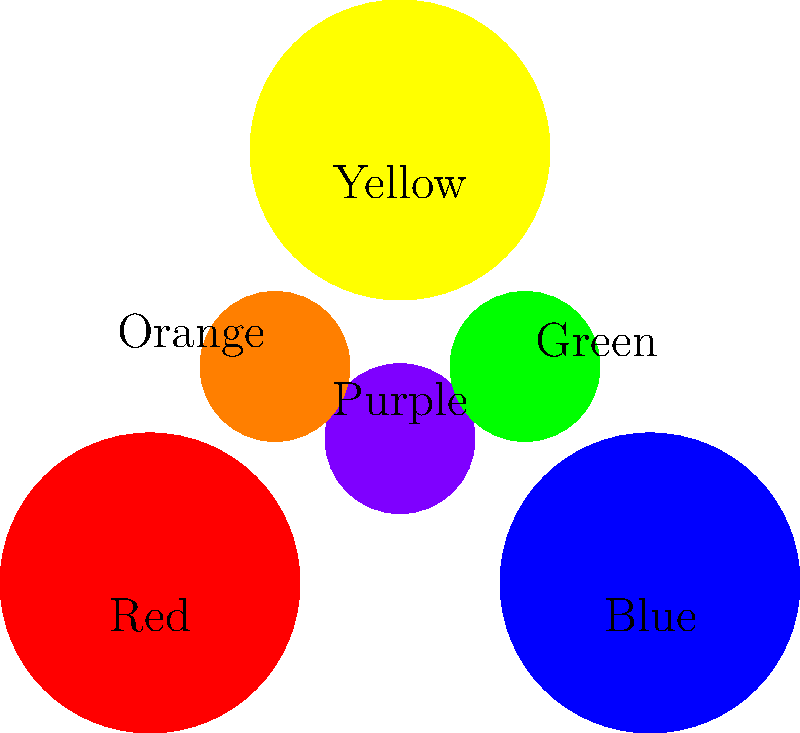Consider the color mixing diagram above, where primary colors (Red, Blue, Yellow) form a group under the operation of color mixing. If we define the group operation * as mixing two colors, and the identity element e as "no color change," what is the result of the following group theory expression?

$$(Red * Blue) * (Yellow * Red^{-1})$$

Assume $Red^{-1}$ represents the color that, when mixed with Red, results in no color change (e). Let's break this down step-by-step using group theory principles:

1) First, let's evaluate $(Red * Blue)$:
   Red * Blue = Purple

2) Next, we need to determine $Red^{-1}$:
   In color theory, the inverse of a primary color is often considered to be its complementary color. The complementary color of Red is Cyan (a mixture of Blue and Yellow).

3) Now we can evaluate $(Yellow * Red^{-1})$:
   Yellow * Cyan = Green
   (Since Cyan contains Blue, and Yellow + Blue = Green)

4) Our expression has now been simplified to:
   Purple * Green

5) When mixing Purple and Green:
   Purple (Red + Blue) + Green (Yellow + Blue) = Red + Blue + Yellow + Blue
   
   Simplifying:
   Red + Yellow + (Blue + Blue)
   
   In color mixing, adding more of the same color intensifies it but doesn't change the resulting color. So we can simplify this to:
   Red + Yellow + Blue

6) The mixture of all three primary colors in equal proportions typically results in a dark color, often interpreted as black or a very dark gray.

Therefore, the final result of the color mixing operation is black (or a very dark gray, depending on the exact proportions).
Answer: Black (or very dark gray) 